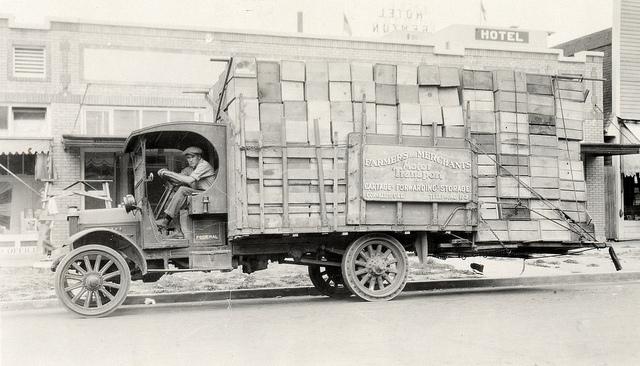What mode of transportation is the person getting into?
Quick response, please. Truck. Where is the truck parked?
Answer briefly. Street. How many people are in this picture?
Answer briefly. 1. How many boxes on the truck?
Concise answer only. 100. Would you like to drive this truck?
Concise answer only. No. 